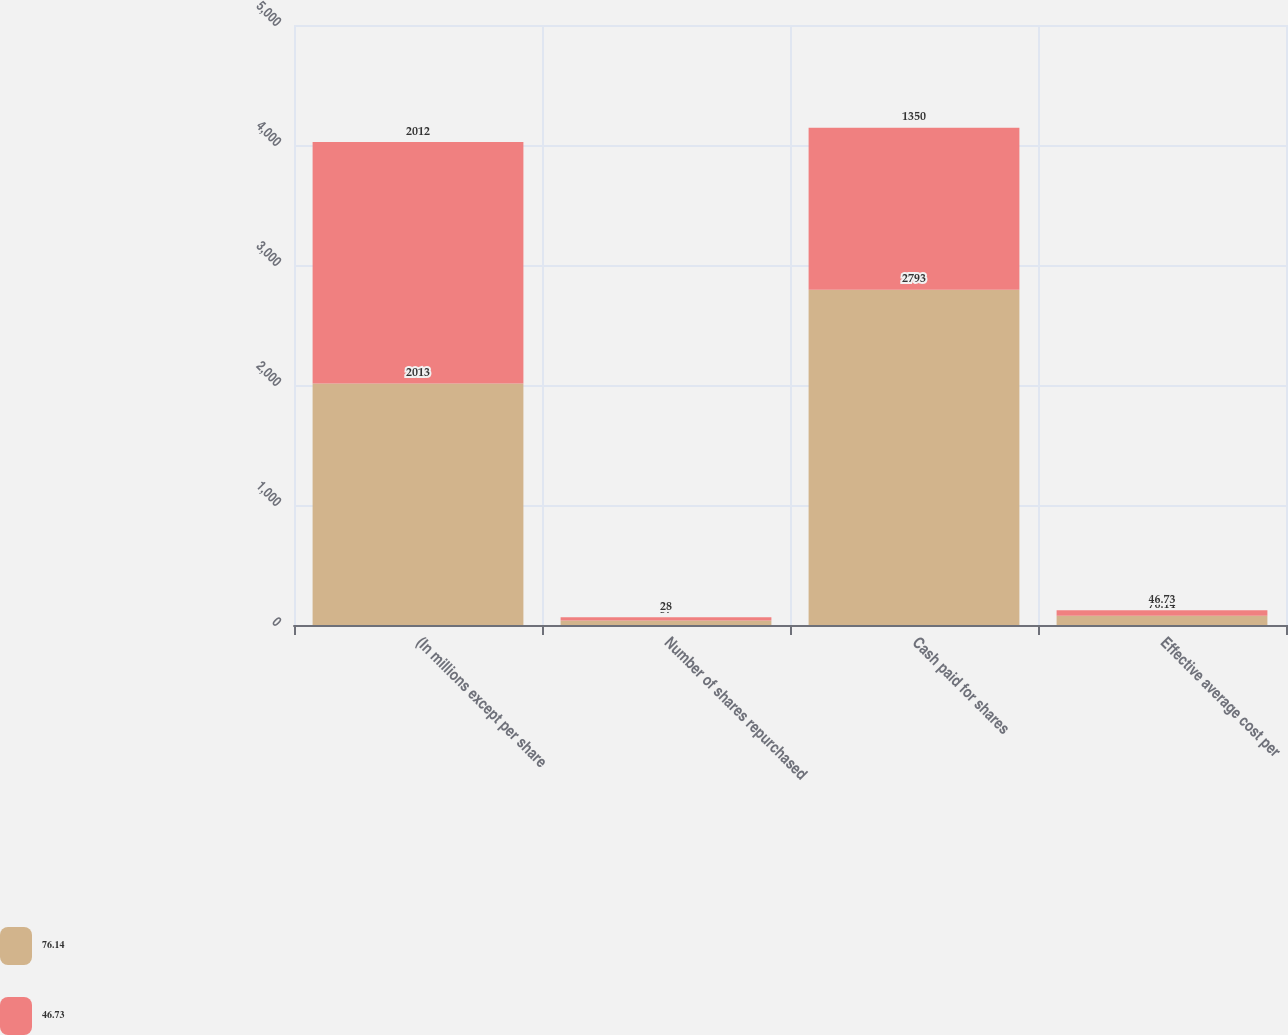<chart> <loc_0><loc_0><loc_500><loc_500><stacked_bar_chart><ecel><fcel>(In millions except per share<fcel>Number of shares repurchased<fcel>Cash paid for shares<fcel>Effective average cost per<nl><fcel>76.14<fcel>2013<fcel>37<fcel>2793<fcel>76.14<nl><fcel>46.73<fcel>2012<fcel>28<fcel>1350<fcel>46.73<nl></chart> 